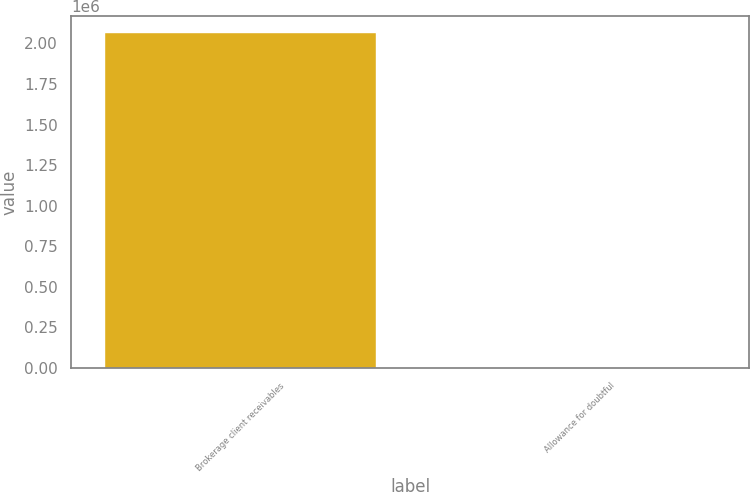Convert chart to OTSL. <chart><loc_0><loc_0><loc_500><loc_500><bar_chart><fcel>Brokerage client receivables<fcel>Allowance for doubtful<nl><fcel>2.06712e+06<fcel>90<nl></chart> 